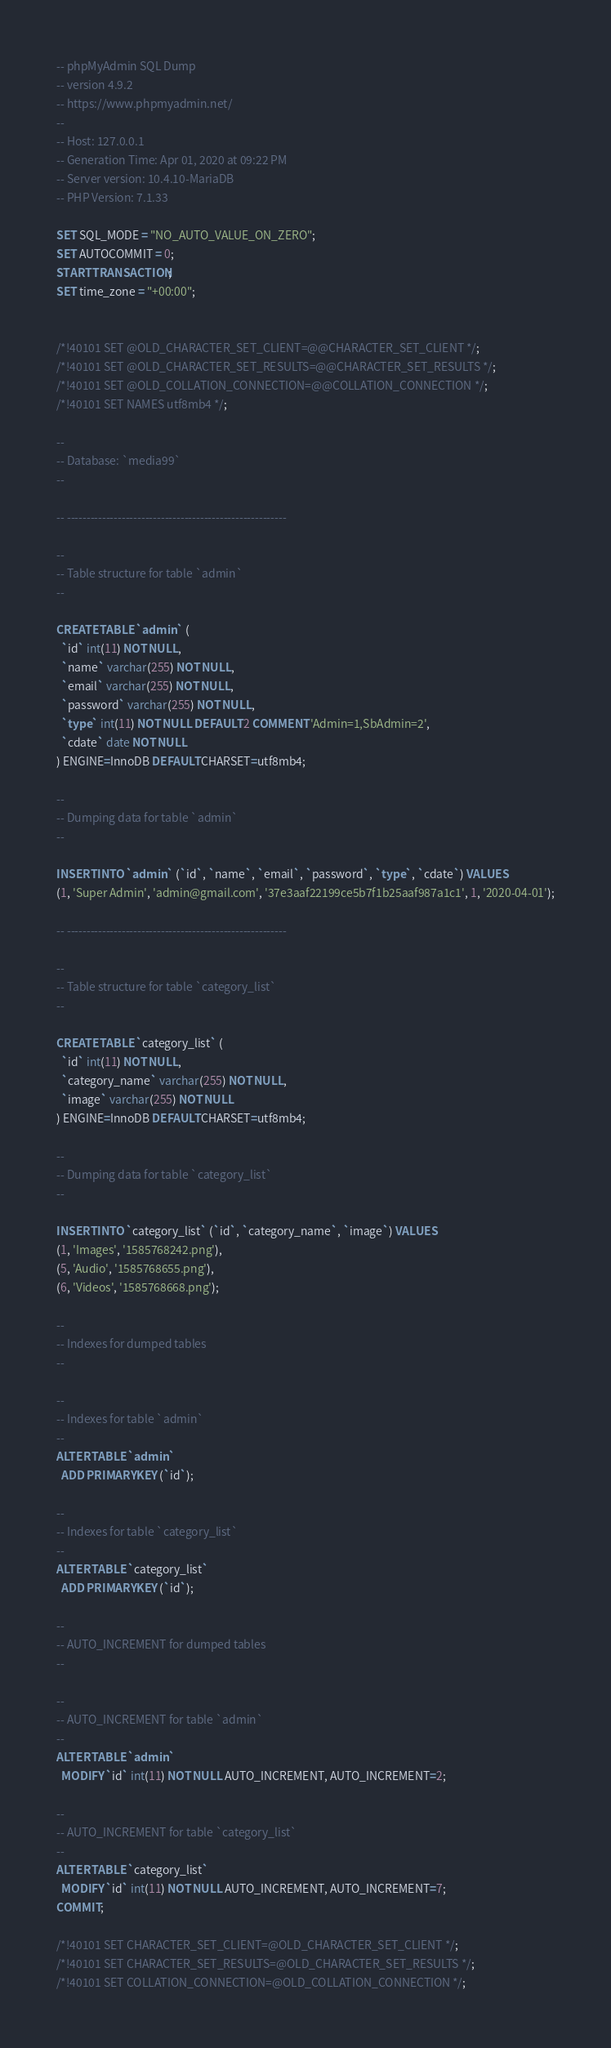<code> <loc_0><loc_0><loc_500><loc_500><_SQL_>-- phpMyAdmin SQL Dump
-- version 4.9.2
-- https://www.phpmyadmin.net/
--
-- Host: 127.0.0.1
-- Generation Time: Apr 01, 2020 at 09:22 PM
-- Server version: 10.4.10-MariaDB
-- PHP Version: 7.1.33

SET SQL_MODE = "NO_AUTO_VALUE_ON_ZERO";
SET AUTOCOMMIT = 0;
START TRANSACTION;
SET time_zone = "+00:00";


/*!40101 SET @OLD_CHARACTER_SET_CLIENT=@@CHARACTER_SET_CLIENT */;
/*!40101 SET @OLD_CHARACTER_SET_RESULTS=@@CHARACTER_SET_RESULTS */;
/*!40101 SET @OLD_COLLATION_CONNECTION=@@COLLATION_CONNECTION */;
/*!40101 SET NAMES utf8mb4 */;

--
-- Database: `media99`
--

-- --------------------------------------------------------

--
-- Table structure for table `admin`
--

CREATE TABLE `admin` (
  `id` int(11) NOT NULL,
  `name` varchar(255) NOT NULL,
  `email` varchar(255) NOT NULL,
  `password` varchar(255) NOT NULL,
  `type` int(11) NOT NULL DEFAULT 2 COMMENT 'Admin=1,SbAdmin=2',
  `cdate` date NOT NULL
) ENGINE=InnoDB DEFAULT CHARSET=utf8mb4;

--
-- Dumping data for table `admin`
--

INSERT INTO `admin` (`id`, `name`, `email`, `password`, `type`, `cdate`) VALUES
(1, 'Super Admin', 'admin@gmail.com', '37e3aaf22199ce5b7f1b25aaf987a1c1', 1, '2020-04-01');

-- --------------------------------------------------------

--
-- Table structure for table `category_list`
--

CREATE TABLE `category_list` (
  `id` int(11) NOT NULL,
  `category_name` varchar(255) NOT NULL,
  `image` varchar(255) NOT NULL
) ENGINE=InnoDB DEFAULT CHARSET=utf8mb4;

--
-- Dumping data for table `category_list`
--

INSERT INTO `category_list` (`id`, `category_name`, `image`) VALUES
(1, 'Images', '1585768242.png'),
(5, 'Audio', '1585768655.png'),
(6, 'Videos', '1585768668.png');

--
-- Indexes for dumped tables
--

--
-- Indexes for table `admin`
--
ALTER TABLE `admin`
  ADD PRIMARY KEY (`id`);

--
-- Indexes for table `category_list`
--
ALTER TABLE `category_list`
  ADD PRIMARY KEY (`id`);

--
-- AUTO_INCREMENT for dumped tables
--

--
-- AUTO_INCREMENT for table `admin`
--
ALTER TABLE `admin`
  MODIFY `id` int(11) NOT NULL AUTO_INCREMENT, AUTO_INCREMENT=2;

--
-- AUTO_INCREMENT for table `category_list`
--
ALTER TABLE `category_list`
  MODIFY `id` int(11) NOT NULL AUTO_INCREMENT, AUTO_INCREMENT=7;
COMMIT;

/*!40101 SET CHARACTER_SET_CLIENT=@OLD_CHARACTER_SET_CLIENT */;
/*!40101 SET CHARACTER_SET_RESULTS=@OLD_CHARACTER_SET_RESULTS */;
/*!40101 SET COLLATION_CONNECTION=@OLD_COLLATION_CONNECTION */;
</code> 